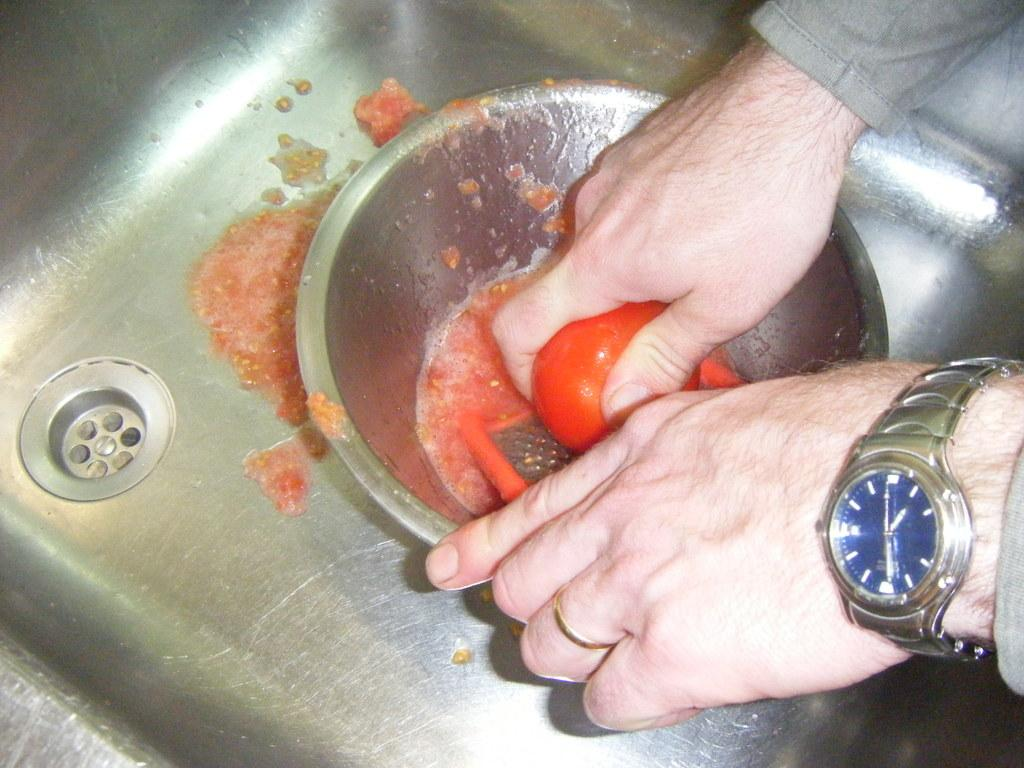What is the person in the image doing? The person is grating a tomato. What tool is being used for grating the tomato? A grater is being used for grating the tomato. Where is the grated tomato placed? The grated tomato is in a bowl. What can be seen near the person in the image? There is a sink in the image. What accessory is the person wearing? The person is wearing a wristwatch. What type of toys can be seen playing with the bird in the image? There are no toys or birds present in the image; it features a person grating a tomato. How does the person's digestion process affect the grated tomato in the image? The person's digestion process is not visible or relevant in the image, as it only shows the person grating a tomato. 